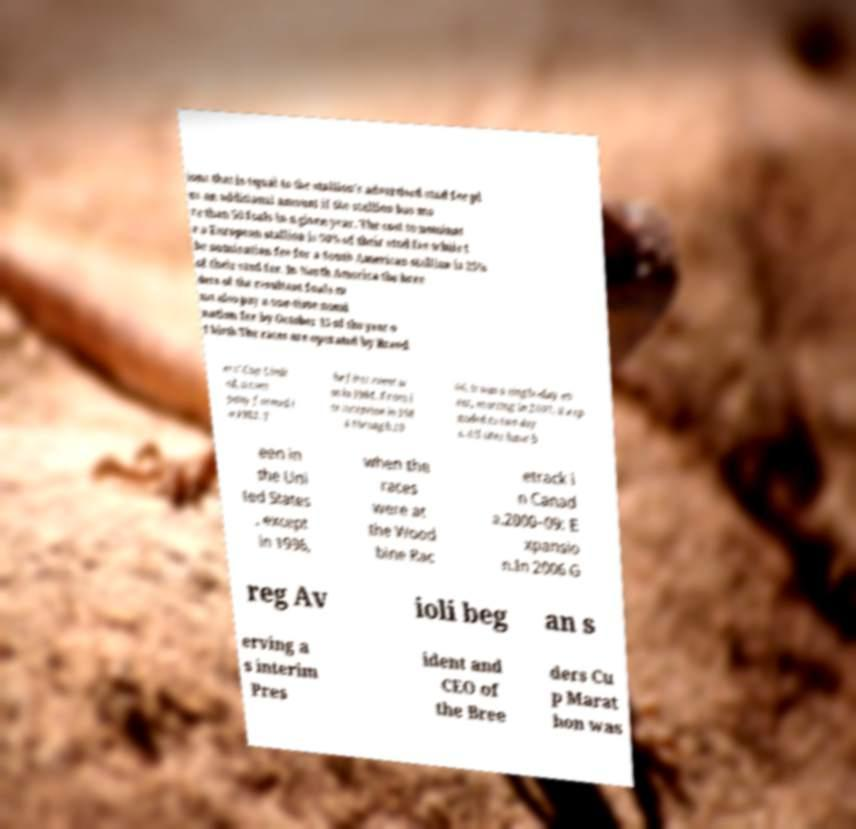Please identify and transcribe the text found in this image. ions that is equal to the stallion's advertised stud fee pl us an additional amount if the stallion has mo re than 50 foals in a given year. The cost to nominat e a European stallion is 50% of their stud fee while t he nomination fee for a South American stallion is 25% of their stud fee. In North America the bree ders of the resultant foals m ust also pay a one-time nomi nation fee by October 15 of the year o f birth.The races are operated by Breed ers' Cup Limit ed, a com pany formed i n 1982. T he first event w as in 1984. From i ts inception in 198 4 through 20 06, it was a single-day ev ent; starting in 2007, it exp anded to two day s. All sites have b een in the Uni ted States , except in 1996, when the races were at the Wood bine Rac etrack i n Canad a.2000–09: E xpansio n.In 2006 G reg Av ioli beg an s erving a s interim Pres ident and CEO of the Bree ders Cu p Marat hon was 